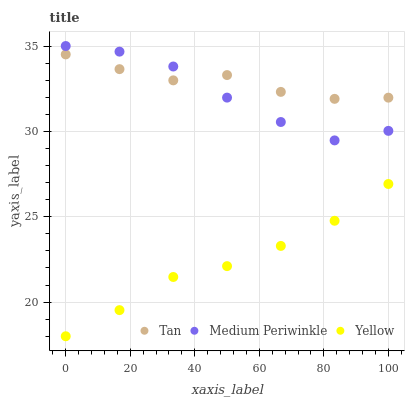Does Yellow have the minimum area under the curve?
Answer yes or no. Yes. Does Tan have the maximum area under the curve?
Answer yes or no. Yes. Does Medium Periwinkle have the minimum area under the curve?
Answer yes or no. No. Does Medium Periwinkle have the maximum area under the curve?
Answer yes or no. No. Is Yellow the smoothest?
Answer yes or no. Yes. Is Medium Periwinkle the roughest?
Answer yes or no. Yes. Is Medium Periwinkle the smoothest?
Answer yes or no. No. Is Yellow the roughest?
Answer yes or no. No. Does Yellow have the lowest value?
Answer yes or no. Yes. Does Medium Periwinkle have the lowest value?
Answer yes or no. No. Does Medium Periwinkle have the highest value?
Answer yes or no. Yes. Does Yellow have the highest value?
Answer yes or no. No. Is Yellow less than Medium Periwinkle?
Answer yes or no. Yes. Is Tan greater than Yellow?
Answer yes or no. Yes. Does Medium Periwinkle intersect Tan?
Answer yes or no. Yes. Is Medium Periwinkle less than Tan?
Answer yes or no. No. Is Medium Periwinkle greater than Tan?
Answer yes or no. No. Does Yellow intersect Medium Periwinkle?
Answer yes or no. No. 